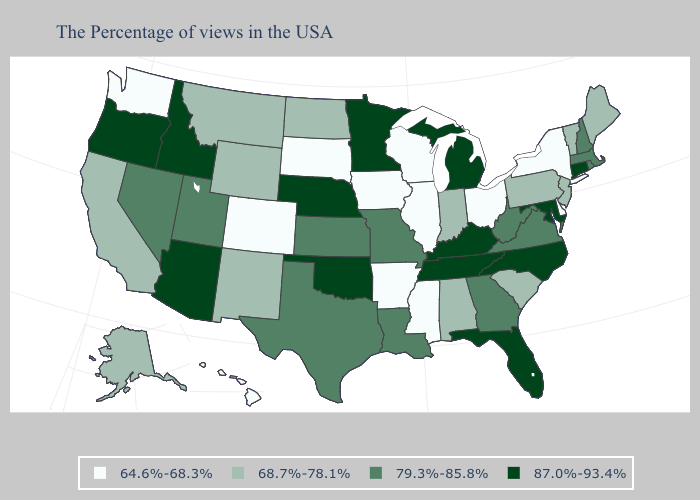Which states have the lowest value in the USA?
Concise answer only. New York, Delaware, Ohio, Wisconsin, Illinois, Mississippi, Arkansas, Iowa, South Dakota, Colorado, Washington, Hawaii. Among the states that border Illinois , which have the highest value?
Keep it brief. Kentucky. Does Louisiana have the highest value in the USA?
Quick response, please. No. Which states hav the highest value in the West?
Concise answer only. Arizona, Idaho, Oregon. Does Oregon have the highest value in the West?
Be succinct. Yes. Name the states that have a value in the range 87.0%-93.4%?
Quick response, please. Connecticut, Maryland, North Carolina, Florida, Michigan, Kentucky, Tennessee, Minnesota, Nebraska, Oklahoma, Arizona, Idaho, Oregon. Does Delaware have the highest value in the South?
Concise answer only. No. What is the value of Oklahoma?
Be succinct. 87.0%-93.4%. Does New Jersey have the highest value in the Northeast?
Concise answer only. No. Name the states that have a value in the range 87.0%-93.4%?
Short answer required. Connecticut, Maryland, North Carolina, Florida, Michigan, Kentucky, Tennessee, Minnesota, Nebraska, Oklahoma, Arizona, Idaho, Oregon. What is the value of Florida?
Give a very brief answer. 87.0%-93.4%. What is the value of Louisiana?
Be succinct. 79.3%-85.8%. Does Virginia have the lowest value in the USA?
Write a very short answer. No. Among the states that border Rhode Island , which have the lowest value?
Short answer required. Massachusetts. Name the states that have a value in the range 87.0%-93.4%?
Write a very short answer. Connecticut, Maryland, North Carolina, Florida, Michigan, Kentucky, Tennessee, Minnesota, Nebraska, Oklahoma, Arizona, Idaho, Oregon. 